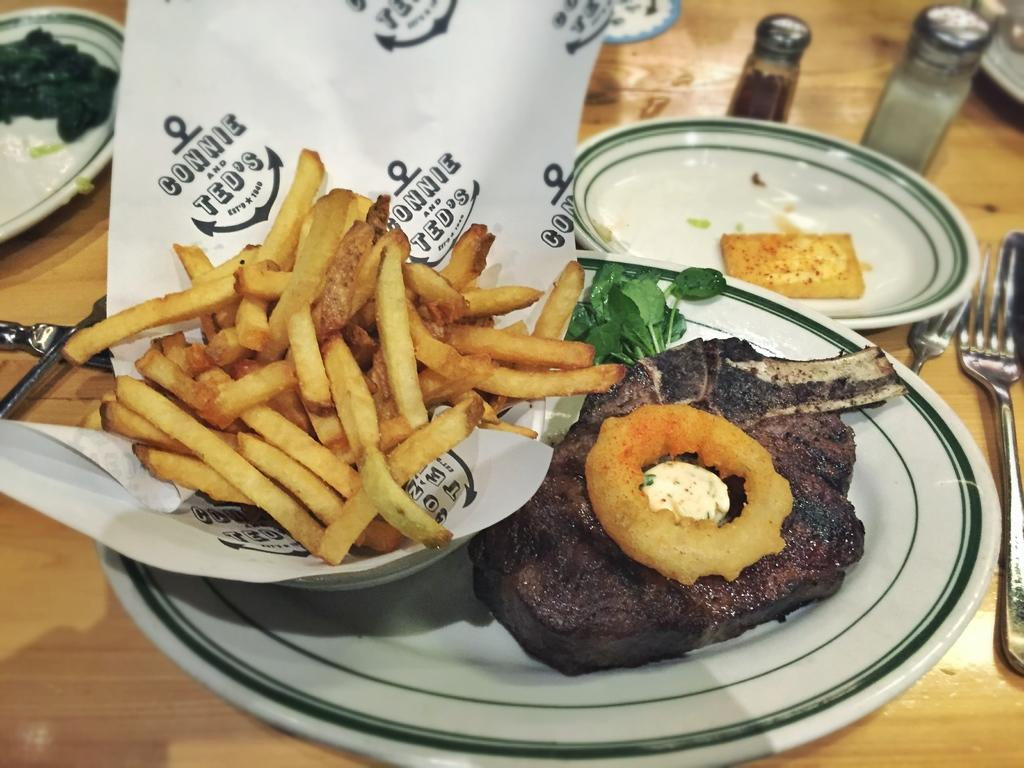What type of items can be seen in the image? There are food items, plates, bottles, and spoons in the image. What colors are the food items? The food items are in brown, green, and cream colors. Where are these items located? All these items are on a table. Can you see any docks or clams in the image? No, there are no docks or clams present in the image. Is there a cable visible in the image? No, there is no cable visible in the image. 